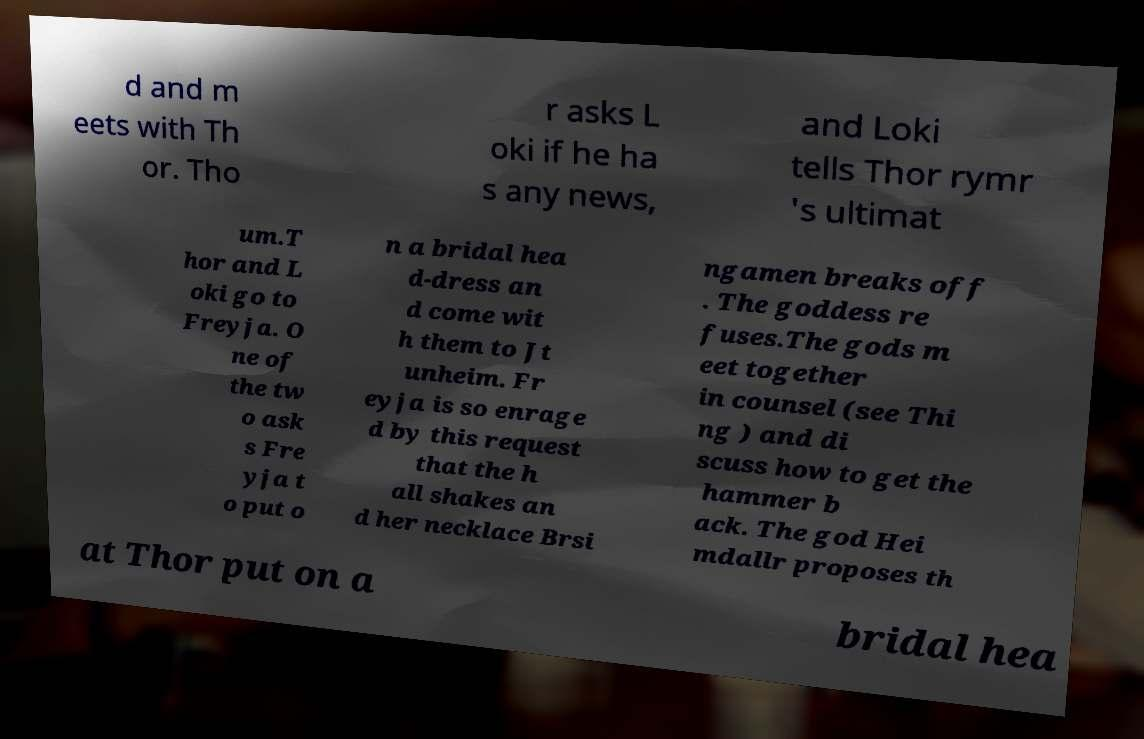There's text embedded in this image that I need extracted. Can you transcribe it verbatim? d and m eets with Th or. Tho r asks L oki if he ha s any news, and Loki tells Thor rymr 's ultimat um.T hor and L oki go to Freyja. O ne of the tw o ask s Fre yja t o put o n a bridal hea d-dress an d come wit h them to Jt unheim. Fr eyja is so enrage d by this request that the h all shakes an d her necklace Brsi ngamen breaks off . The goddess re fuses.The gods m eet together in counsel (see Thi ng ) and di scuss how to get the hammer b ack. The god Hei mdallr proposes th at Thor put on a bridal hea 